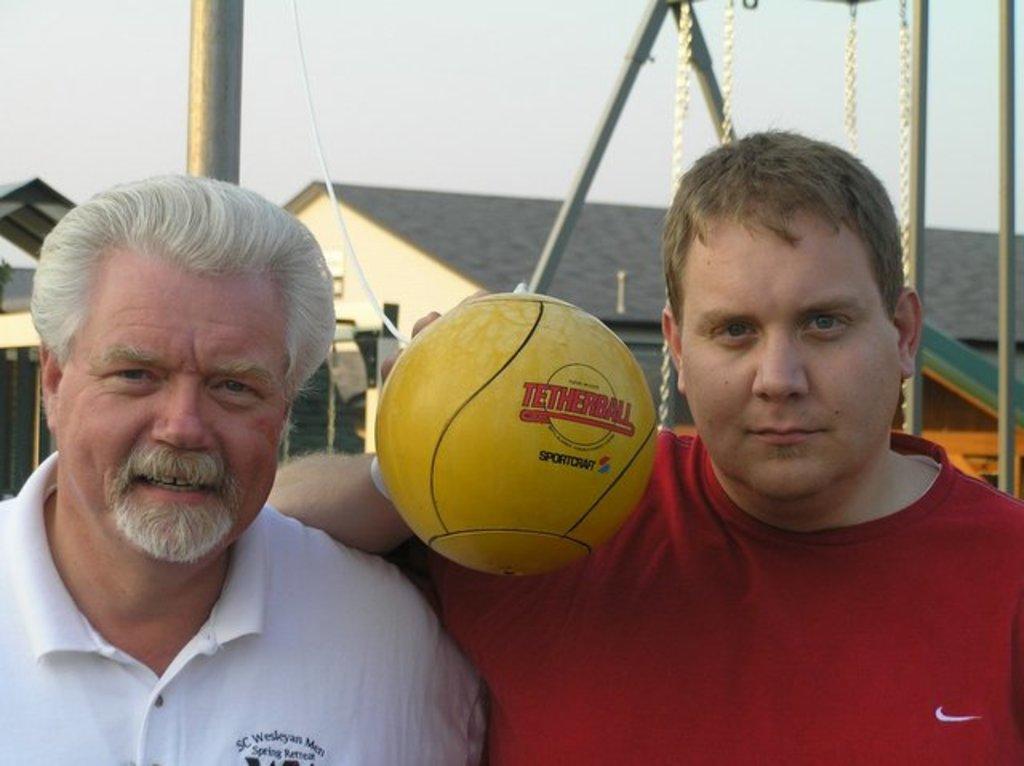Please provide a concise description of this image. In this picture a person is standing he is wearing a white t-shirt, and beside him a man is standing he is wearing a red t-shirt, he is holding a ball in his hand. and back of them there is a house ,and here is a metal rod ,and the sky is cloudy. 